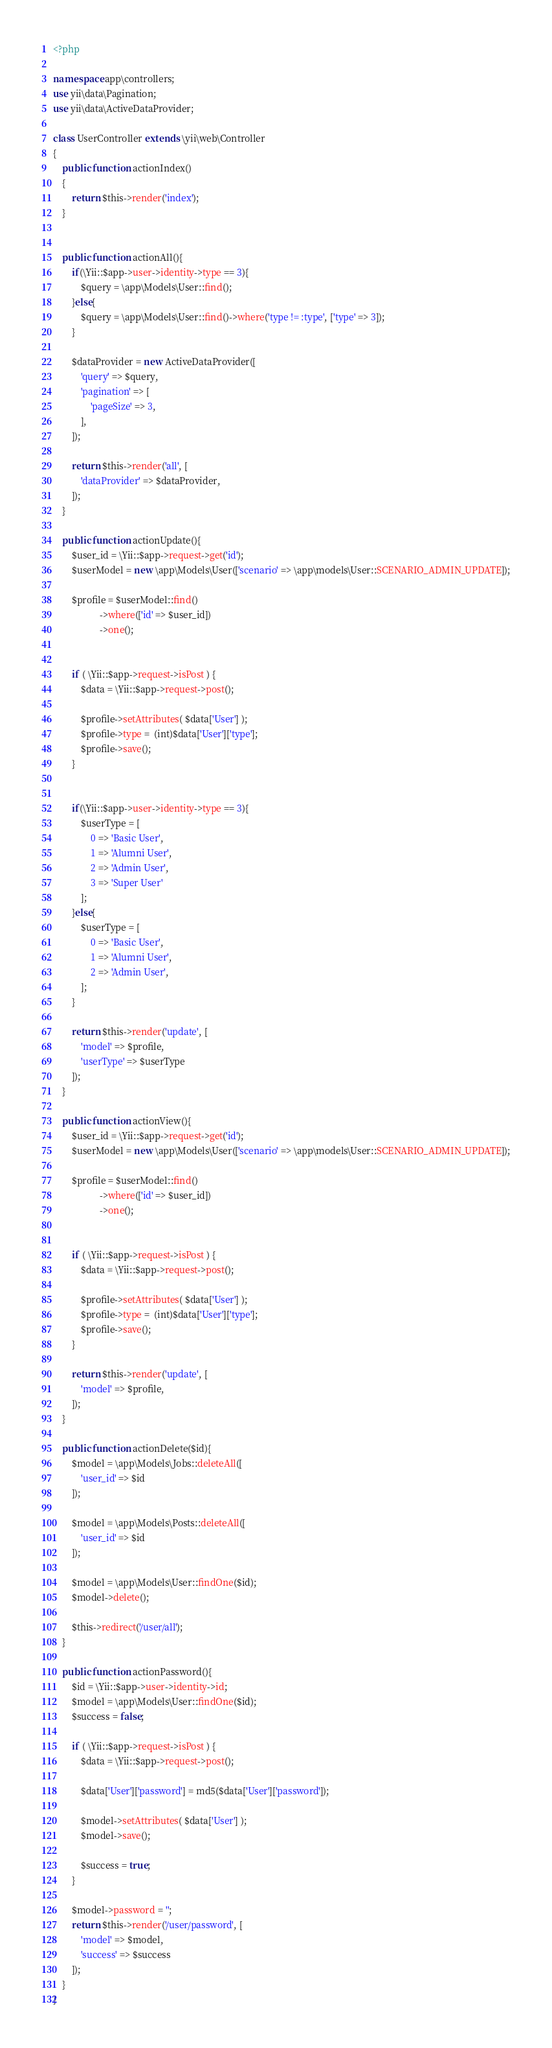<code> <loc_0><loc_0><loc_500><loc_500><_PHP_><?php

namespace app\controllers;
use yii\data\Pagination;
use yii\data\ActiveDataProvider;

class UserController extends \yii\web\Controller
{
    public function actionIndex()
    {
        return $this->render('index');
    }


    public function actionAll(){
        if(\Yii::$app->user->identity->type == 3){
            $query = \app\Models\User::find();
        }else{
            $query = \app\Models\User::find()->where('type != :type', ['type' => 3]);
        }

        $dataProvider = new ActiveDataProvider([
            'query' => $query,
            'pagination' => [
                'pageSize' => 3,
            ],
        ]);

        return $this->render('all', [
            'dataProvider' => $dataProvider,
        ]);
    }

    public function actionUpdate(){
        $user_id = \Yii::$app->request->get('id');
        $userModel = new \app\Models\User(['scenario' => \app\models\User::SCENARIO_ADMIN_UPDATE]);

        $profile = $userModel::find()
                    ->where(['id' => $user_id])
                    ->one();


        if ( \Yii::$app->request->isPost ) {
            $data = \Yii::$app->request->post();

            $profile->setAttributes( $data['User'] );
            $profile->type =  (int)$data['User']['type'];
            $profile->save();
        }


        if(\Yii::$app->user->identity->type == 3){
            $userType = [
                0 => 'Basic User',
                1 => 'Alumni User',
                2 => 'Admin User',
                3 => 'Super User'
            ];
        }else{
            $userType = [
                0 => 'Basic User',
                1 => 'Alumni User',
                2 => 'Admin User',
            ];
        }

        return $this->render('update', [
            'model' => $profile,
            'userType' => $userType
        ]);
    }

    public function actionView(){
        $user_id = \Yii::$app->request->get('id');
        $userModel = new \app\Models\User(['scenario' => \app\models\User::SCENARIO_ADMIN_UPDATE]);

        $profile = $userModel::find()
                    ->where(['id' => $user_id])
                    ->one();


        if ( \Yii::$app->request->isPost ) {
            $data = \Yii::$app->request->post();

            $profile->setAttributes( $data['User'] );
            $profile->type =  (int)$data['User']['type'];
            $profile->save();
        }

        return $this->render('update', [
            'model' => $profile,
        ]);
    }

    public function actionDelete($id){
        $model = \app\Models\Jobs::deleteAll([
            'user_id' => $id
        ]);

        $model = \app\Models\Posts::deleteAll([
            'user_id' => $id
        ]);

        $model = \app\Models\User::findOne($id);
        $model->delete();

        $this->redirect('/user/all');
    }

    public function actionPassword(){
        $id = \Yii::$app->user->identity->id;
        $model = \app\Models\User::findOne($id);
        $success = false;

        if ( \Yii::$app->request->isPost ) {
            $data = \Yii::$app->request->post();

            $data['User']['password'] = md5($data['User']['password']);

            $model->setAttributes( $data['User'] );
            $model->save();

            $success = true;
        }

        $model->password = '';
        return $this->render('/user/password', [
            'model' => $model,
            'success' => $success
        ]);
    }
}
</code> 